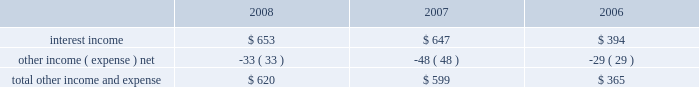Table of contents related to mac os x version 10.6 snow leopard and excluded from r&d expense , while r&d expense for 2007 excluded $ 75 million of capitalized software development costs related to mac os x leopard and iphone .
Although total r&d expense increased 42% ( 42 % ) during 2008 , it remained relatively flat as a percentage of net sales given the 35% ( 35 % ) increase in revenue during 2008 .
The company continues to believe that focused investments in r&d are critical to its future growth and competitive position in the marketplace and are directly related to timely development of new and enhanced products that are central to the company 2019s core business strategy .
As such , the company expects to increase spending in r&d to remain competitive .
Expenditures for r&d increased 10% ( 10 % ) or $ 70 million to $ 782 million in 2007 compared to 2006 .
The increases in r&d expense were due primarily to an increase in r&d headcount in 2007 to support expanded r&d activities , partially offset by one less week of expenses in the first quarter of 2007 and the capitalized software development costs mentioned above .
Selling , general , and administrative expense ( 201csg&a 201d ) expenditures for sg&a increased $ 798 million or 27% ( 27 % ) to $ 3.8 billion in 2008 compared to 2007 .
These increases are due primarily to higher stock-based compensation expenses , higher variable selling expenses resulting from the significant year-over-year increase in total net sales and the company 2019s continued expansion of its retail segment in both domestic and international markets .
In addition , the company incurred higher spending on marketing and advertising during 2008 compared to 2007 .
Expenditures for sg&a increased $ 530 million or 22% ( 22 % ) during 2007 compared to 2006 .
The increase was due primarily to higher direct and indirect channel variable selling expenses resulting from the significant year-over-year increase in total net sales in 2007 , the company 2019s continued expansion of its retail segment in both domestic and international markets , and higher spending on marketing and advertising , partially offset by one less week of expenses in the first quarter of 2007 .
Other income and expense other income and expense for the three fiscal years ended september 27 , 2008 , are as follows ( in millions ) : total other income and expense increased $ 21 million to $ 620 million during 2008 as compared to $ 599 million and $ 365 million in 2007 and 2006 , respectively .
While the company 2019s cash , cash equivalents and short-term investment balances increased by 59% ( 59 % ) in 2008 , other income and expense increased only 4% ( 4 % ) due to the decline in the weighted average interest rate earned of 3.44% ( 3.44 % ) .
The overall increase in other income and expense is attributable to the company 2019s higher cash and short-term investment balances , which more than offset the decline in interest rates during 2008 as compared to 2007 .
The weighted average interest rate earned by the company on its cash , cash equivalents , and short-term investments was 5.27% ( 5.27 % ) and 4.58% ( 4.58 % ) during 2007 and 2006 , respectively .
During 2008 , 2007 and 2006 , the company had no debt outstanding and accordingly did not incur any related interest expense .
Provision for income taxes the company 2019s effective tax rates were 30% ( 30 % ) for the years ended september 27 , 2008 and september 29 , 2007 , and 29% ( 29 % ) for the year ended september 30 , 2006 .
The company 2019s effective rates differ from the statutory federal income tax rate of 35% ( 35 % ) due primarily to certain undistributed foreign earnings for which no u.s .
Taxes are provided because such earnings are intended to be indefinitely reinvested outside the as of september 27 , 2008 , the company had deferred tax assets arising from deductible temporary differences , tax losses , and tax credits of $ 2.1 billion before being offset against certain deferred liabilities for presentation on the company 2019s balance sheet .
Management believes it is more likely than not that forecasted income , including .

What was the greatest interest income , in millions , for the three year period? 
Computations: table_max(interest income, none)
Answer: 653.0. Table of contents related to mac os x version 10.6 snow leopard and excluded from r&d expense , while r&d expense for 2007 excluded $ 75 million of capitalized software development costs related to mac os x leopard and iphone .
Although total r&d expense increased 42% ( 42 % ) during 2008 , it remained relatively flat as a percentage of net sales given the 35% ( 35 % ) increase in revenue during 2008 .
The company continues to believe that focused investments in r&d are critical to its future growth and competitive position in the marketplace and are directly related to timely development of new and enhanced products that are central to the company 2019s core business strategy .
As such , the company expects to increase spending in r&d to remain competitive .
Expenditures for r&d increased 10% ( 10 % ) or $ 70 million to $ 782 million in 2007 compared to 2006 .
The increases in r&d expense were due primarily to an increase in r&d headcount in 2007 to support expanded r&d activities , partially offset by one less week of expenses in the first quarter of 2007 and the capitalized software development costs mentioned above .
Selling , general , and administrative expense ( 201csg&a 201d ) expenditures for sg&a increased $ 798 million or 27% ( 27 % ) to $ 3.8 billion in 2008 compared to 2007 .
These increases are due primarily to higher stock-based compensation expenses , higher variable selling expenses resulting from the significant year-over-year increase in total net sales and the company 2019s continued expansion of its retail segment in both domestic and international markets .
In addition , the company incurred higher spending on marketing and advertising during 2008 compared to 2007 .
Expenditures for sg&a increased $ 530 million or 22% ( 22 % ) during 2007 compared to 2006 .
The increase was due primarily to higher direct and indirect channel variable selling expenses resulting from the significant year-over-year increase in total net sales in 2007 , the company 2019s continued expansion of its retail segment in both domestic and international markets , and higher spending on marketing and advertising , partially offset by one less week of expenses in the first quarter of 2007 .
Other income and expense other income and expense for the three fiscal years ended september 27 , 2008 , are as follows ( in millions ) : total other income and expense increased $ 21 million to $ 620 million during 2008 as compared to $ 599 million and $ 365 million in 2007 and 2006 , respectively .
While the company 2019s cash , cash equivalents and short-term investment balances increased by 59% ( 59 % ) in 2008 , other income and expense increased only 4% ( 4 % ) due to the decline in the weighted average interest rate earned of 3.44% ( 3.44 % ) .
The overall increase in other income and expense is attributable to the company 2019s higher cash and short-term investment balances , which more than offset the decline in interest rates during 2008 as compared to 2007 .
The weighted average interest rate earned by the company on its cash , cash equivalents , and short-term investments was 5.27% ( 5.27 % ) and 4.58% ( 4.58 % ) during 2007 and 2006 , respectively .
During 2008 , 2007 and 2006 , the company had no debt outstanding and accordingly did not incur any related interest expense .
Provision for income taxes the company 2019s effective tax rates were 30% ( 30 % ) for the years ended september 27 , 2008 and september 29 , 2007 , and 29% ( 29 % ) for the year ended september 30 , 2006 .
The company 2019s effective rates differ from the statutory federal income tax rate of 35% ( 35 % ) due primarily to certain undistributed foreign earnings for which no u.s .
Taxes are provided because such earnings are intended to be indefinitely reinvested outside the as of september 27 , 2008 , the company had deferred tax assets arising from deductible temporary differences , tax losses , and tax credits of $ 2.1 billion before being offset against certain deferred liabilities for presentation on the company 2019s balance sheet .
Management believes it is more likely than not that forecasted income , including .

What was the change in the weighted average interest rate earned by the company on its cash , cash equivalents , and short-term investments between 2007 and 2006? 
Computations: (5.27 - 4.58)
Answer: 0.69. 